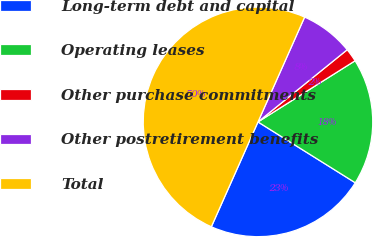Convert chart. <chart><loc_0><loc_0><loc_500><loc_500><pie_chart><fcel>Long-term debt and capital<fcel>Operating leases<fcel>Other purchase commitments<fcel>Other postretirement benefits<fcel>Total<nl><fcel>22.77%<fcel>17.84%<fcel>1.88%<fcel>7.51%<fcel>50.0%<nl></chart> 